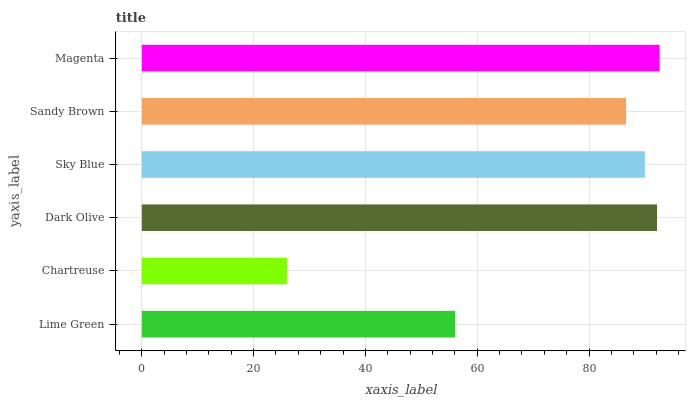Is Chartreuse the minimum?
Answer yes or no. Yes. Is Magenta the maximum?
Answer yes or no. Yes. Is Dark Olive the minimum?
Answer yes or no. No. Is Dark Olive the maximum?
Answer yes or no. No. Is Dark Olive greater than Chartreuse?
Answer yes or no. Yes. Is Chartreuse less than Dark Olive?
Answer yes or no. Yes. Is Chartreuse greater than Dark Olive?
Answer yes or no. No. Is Dark Olive less than Chartreuse?
Answer yes or no. No. Is Sky Blue the high median?
Answer yes or no. Yes. Is Sandy Brown the low median?
Answer yes or no. Yes. Is Dark Olive the high median?
Answer yes or no. No. Is Chartreuse the low median?
Answer yes or no. No. 